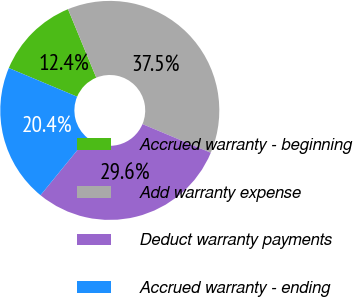Convert chart to OTSL. <chart><loc_0><loc_0><loc_500><loc_500><pie_chart><fcel>Accrued warranty - beginning<fcel>Add warranty expense<fcel>Deduct warranty payments<fcel>Accrued warranty - ending<nl><fcel>12.45%<fcel>37.55%<fcel>29.58%<fcel>20.42%<nl></chart> 